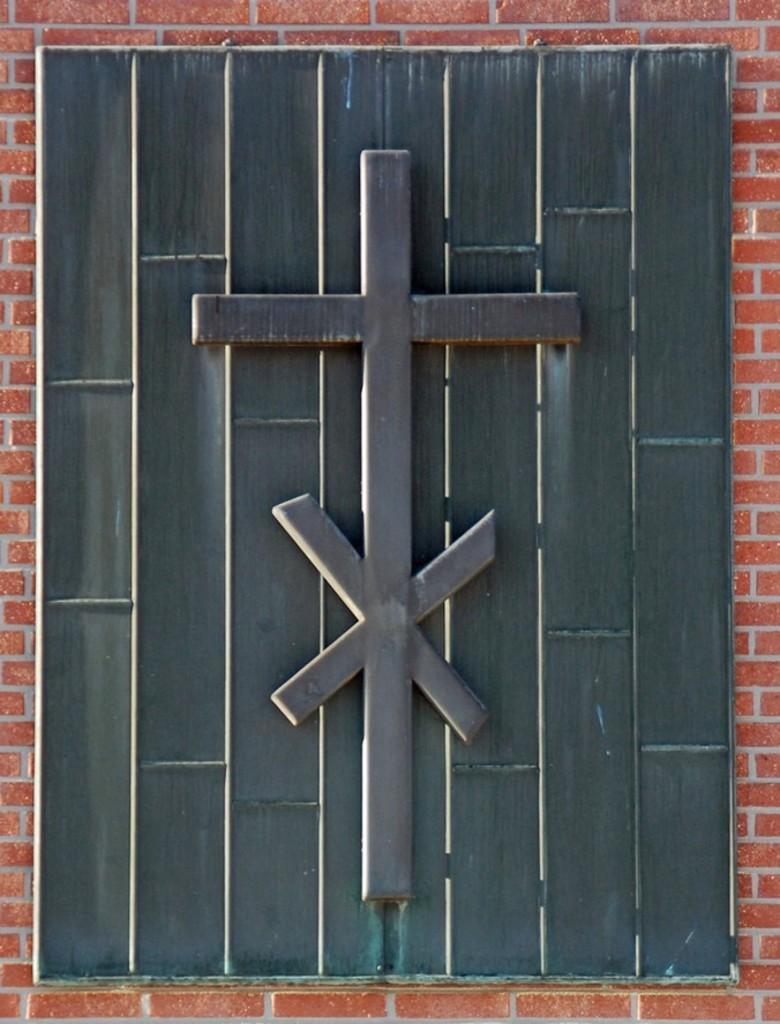How would you summarize this image in a sentence or two? In the foreground of this image, it seems to be a window to a wall. 